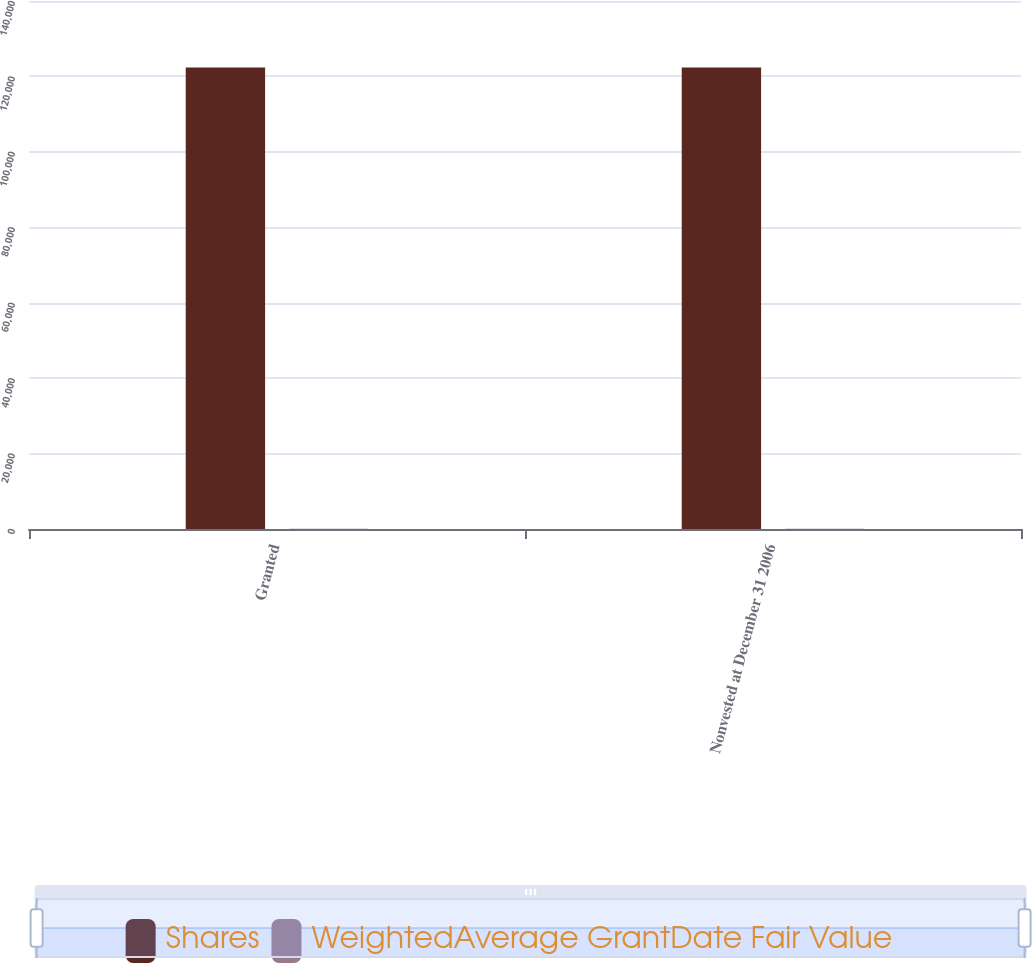<chart> <loc_0><loc_0><loc_500><loc_500><stacked_bar_chart><ecel><fcel>Granted<fcel>Nonvested at December 31 2006<nl><fcel>Shares<fcel>122400<fcel>122400<nl><fcel>WeightedAverage GrantDate Fair Value<fcel>86.05<fcel>86.05<nl></chart> 